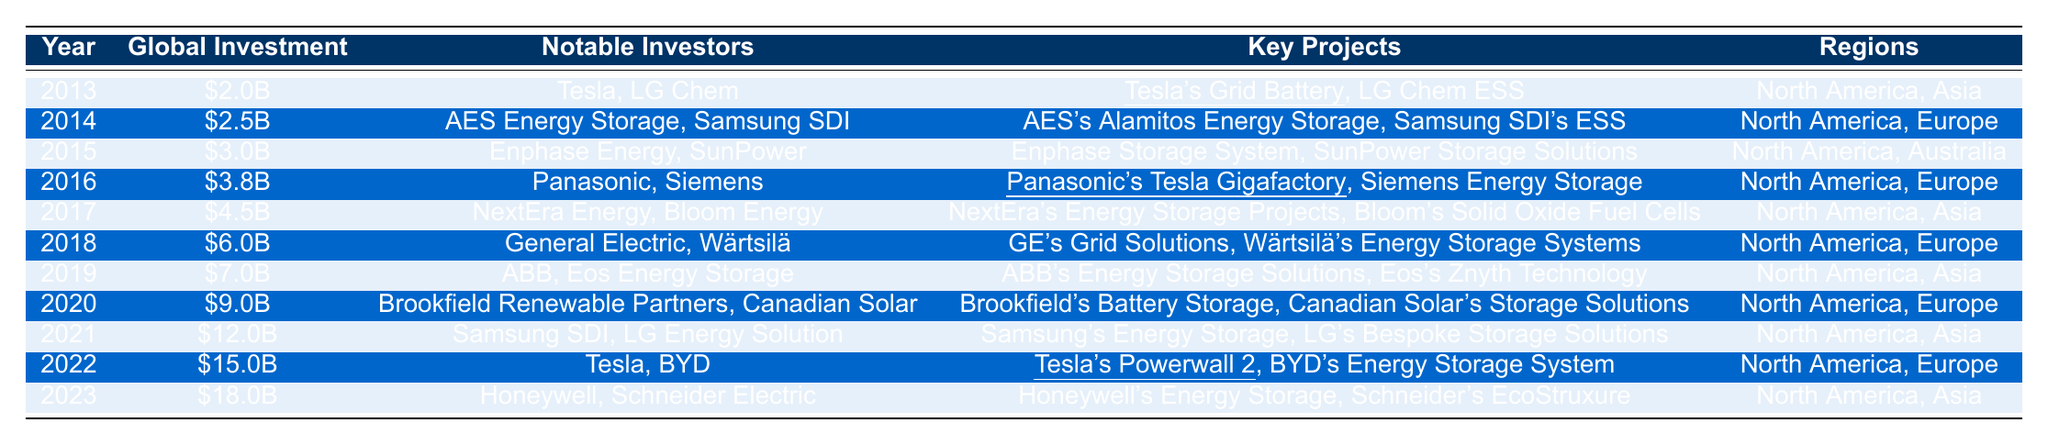What was the global investment in energy storage solutions in 2018? The table shows that the global investment in 2018 was \$6.0 billion.
Answer: \$6.0 billion Who were the notable investors in 2021? The table lists Samsung SDI and LG Energy Solution as the notable investors for the year 2021.
Answer: Samsung SDI, LG Energy Solution What are the key projects highlighted in 2022? The table indicates that Tesla's Powerwall 2 and BYD's Energy Storage System were the key projects in 2022.
Answer: Tesla's Powerwall 2, BYD's Energy Storage System Which year saw the highest global investment, and how much was it? According to the table, the highest global investment was \$18.0 billion in 2023.
Answer: 2023, \$18.0 billion How much did global investment increase from 2013 to 2023? In 2013, the investment was \$2.0 billion and in 2023, it was \$18.0 billion. The increase is \$18.0 billion - \$2.0 billion = \$16.0 billion.
Answer: \$16.0 billion Which notable investors were involved in projects in both North America and Asia in 2017? In 2017, NextEra Energy and Bloom Energy were the notable investors, and they were involved in projects in North America and Asia.
Answer: NextEra Energy, Bloom Energy Is Tesla a notable investor every year from 2013 to 2023? The table indicates that Tesla is a notable investor in 2013, 2018, and 2022, but not in every year. Thus, the statement is false.
Answer: No What was the average global investment from 2015 to 2020? The investments from 2015 to 2020 are \$3.0 billion, \$3.8 billion, \$4.5 billion, \$6.0 billion, \$7.0 billion, and \$9.0 billion. The total is \$3.0B + \$3.8B + \$4.5B + \$6.0B + \$7.0B + \$9.0B = \$33.3 billion. There are 6 years, so the average is \$33.3 billion / 6 = \$5.55 billion.
Answer: \$5.55 billion What is the difference in global investment between the years 2022 and 2020? In 2022, the investment was \$15.0 billion and in 2020, it was \$9.0 billion. The difference is \$15.0 billion - \$9.0 billion = \$6.0 billion.
Answer: \$6.0 billion Which regions were common for notable investments in 2014 and 2016? Both 2014 and 2016 had North America as a common region; Europe was also a region mentioned in 2014, while Asia was mentioned in 2016, so the only common region is North America.
Answer: North America 